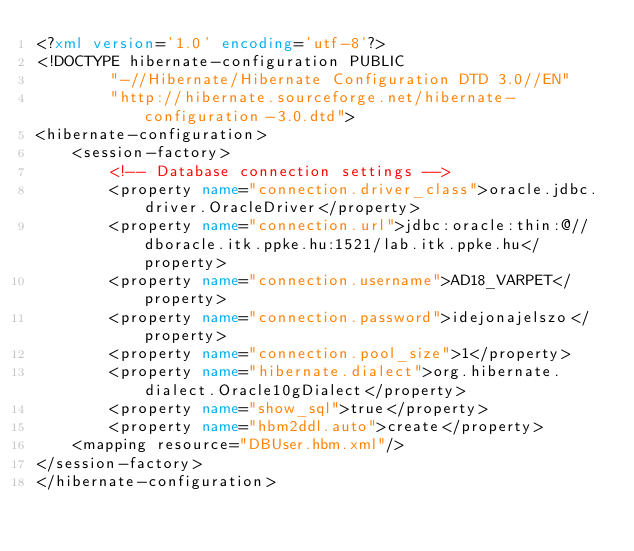<code> <loc_0><loc_0><loc_500><loc_500><_XML_><?xml version='1.0' encoding='utf-8'?>
<!DOCTYPE hibernate-configuration PUBLIC
        "-//Hibernate/Hibernate Configuration DTD 3.0//EN"
        "http://hibernate.sourceforge.net/hibernate-configuration-3.0.dtd">
<hibernate-configuration>
    <session-factory>
        <!-- Database connection settings -->
        <property name="connection.driver_class">oracle.jdbc.driver.OracleDriver</property>
        <property name="connection.url">jdbc:oracle:thin:@//dboracle.itk.ppke.hu:1521/lab.itk.ppke.hu</property>
        <property name="connection.username">AD18_VARPET</property>
        <property name="connection.password">idejonajelszo</property>
        <property name="connection.pool_size">1</property>
        <property name="hibernate.dialect">org.hibernate.dialect.Oracle10gDialect</property>
        <property name="show_sql">true</property>
        <property name="hbm2ddl.auto">create</property>
		<mapping resource="DBUser.hbm.xml"/>
</session-factory>
</hibernate-configuration>
</code> 